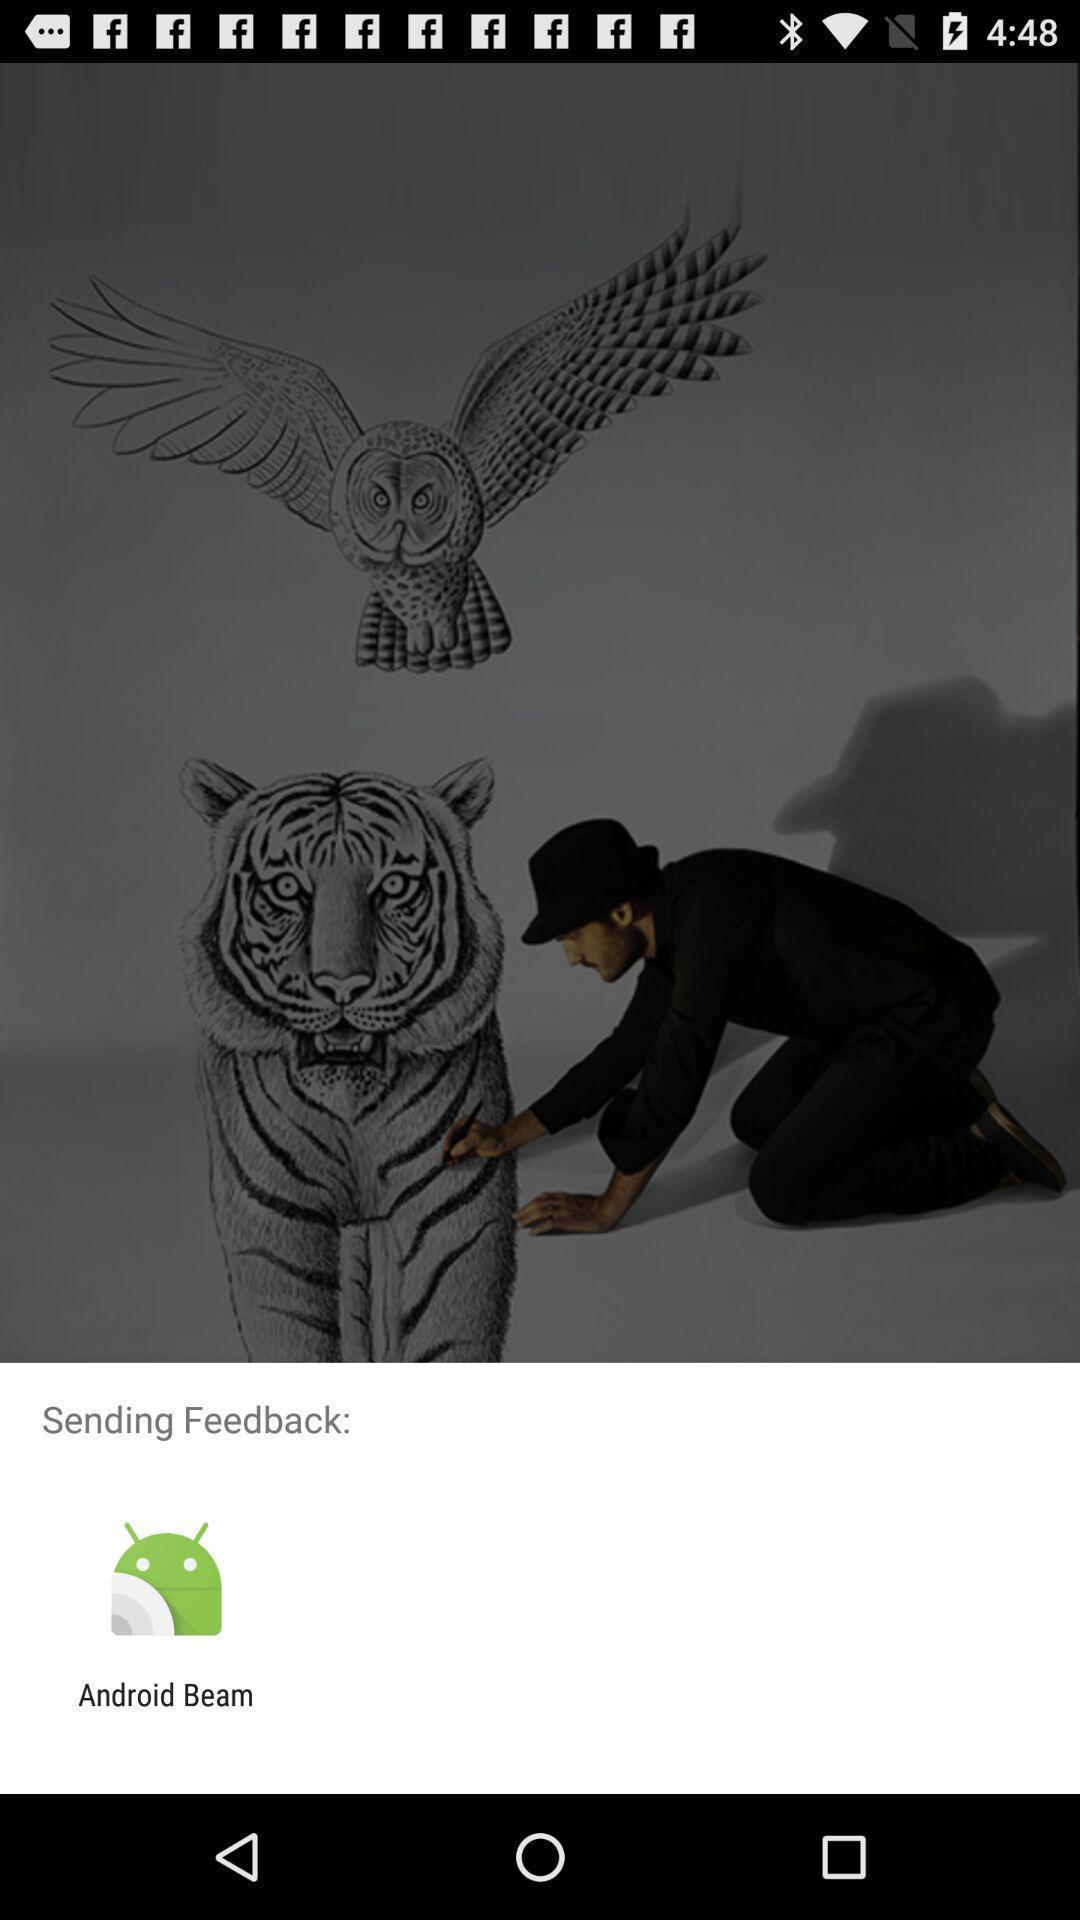Tell me what you see in this picture. Pop-up asking to share a feedback with an app. 